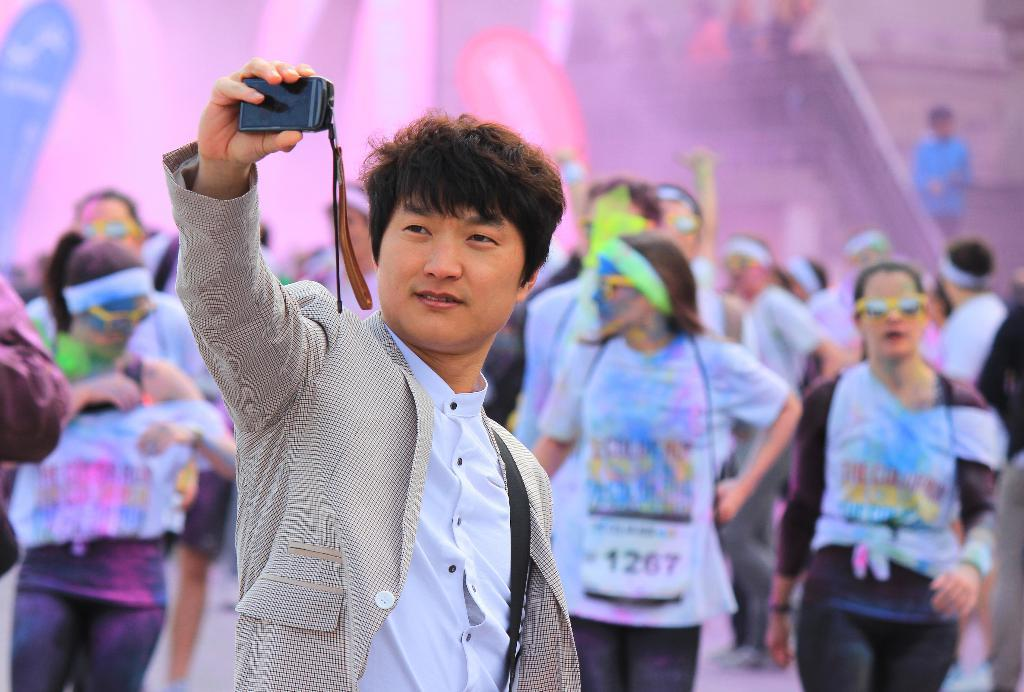What is the person in the foreground holding in the image? A: The person is holding a mobile in the image. What can be seen in the background of the image? There are many people in the background, some of whom are wearing goggles, have chest numbers, and are wearing headbands. What is the condition of the background in the image? The background is blurred. What type of bird can be seen flying in the image? There is no bird visible in the image. What type of milk is being consumed by the people in the background? There is no milk present in the image. 